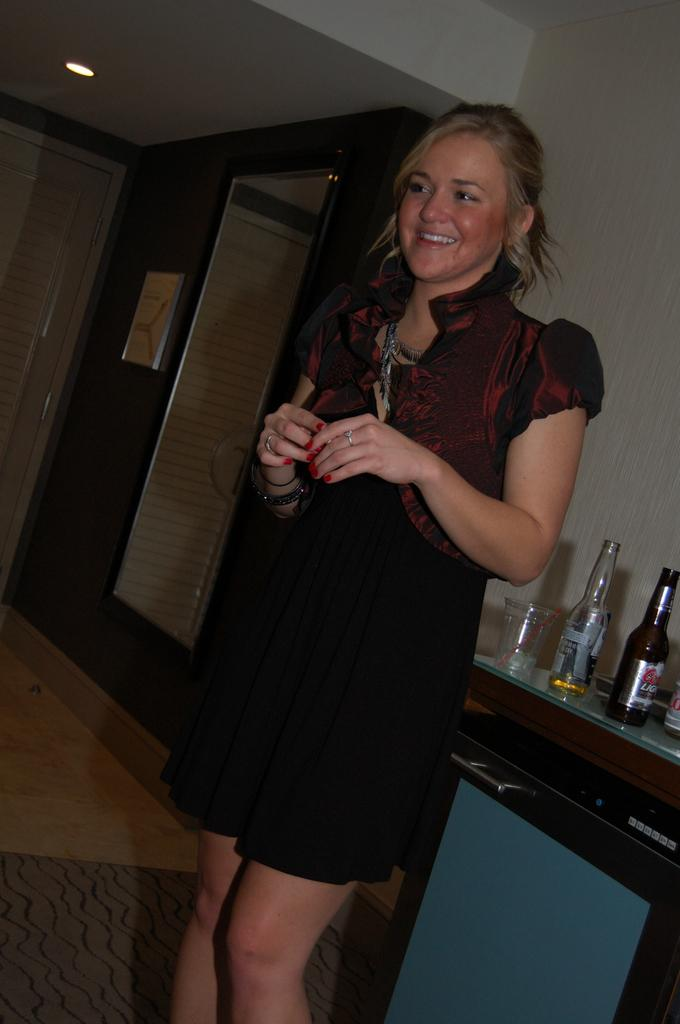Who is present in the image? There is a woman in the image. What is the woman doing in the image? The woman is standing. What objects are on the table in the image? There are wine bottles and a glass on the table. How much wealth does the room in the image represent? There is no room present in the image, and therefore no wealth can be associated with it. 